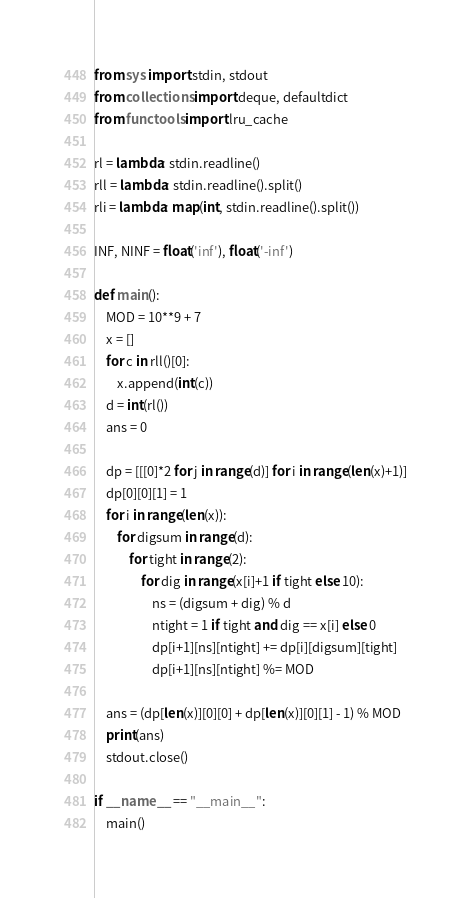Convert code to text. <code><loc_0><loc_0><loc_500><loc_500><_Python_>from sys import stdin, stdout
from collections import deque, defaultdict
from functools import lru_cache

rl = lambda: stdin.readline()
rll = lambda: stdin.readline().split()
rli = lambda: map(int, stdin.readline().split())

INF, NINF = float('inf'), float('-inf')

def main():
	MOD = 10**9 + 7
	x = []
	for c in rll()[0]:
		x.append(int(c))
	d = int(rl())
	ans = 0

	dp = [[[0]*2 for j in range(d)] for i in range(len(x)+1)]
	dp[0][0][1] = 1
	for i in range(len(x)):
		for digsum in range(d):
			for tight in range(2):
				for dig in range(x[i]+1 if tight else 10):
					ns = (digsum + dig) % d 
					ntight = 1 if tight and dig == x[i] else 0
					dp[i+1][ns][ntight] += dp[i][digsum][tight]
					dp[i+1][ns][ntight] %= MOD

	ans = (dp[len(x)][0][0] + dp[len(x)][0][1] - 1) % MOD
	print(ans)
	stdout.close()

if __name__ == "__main__":
	main()</code> 